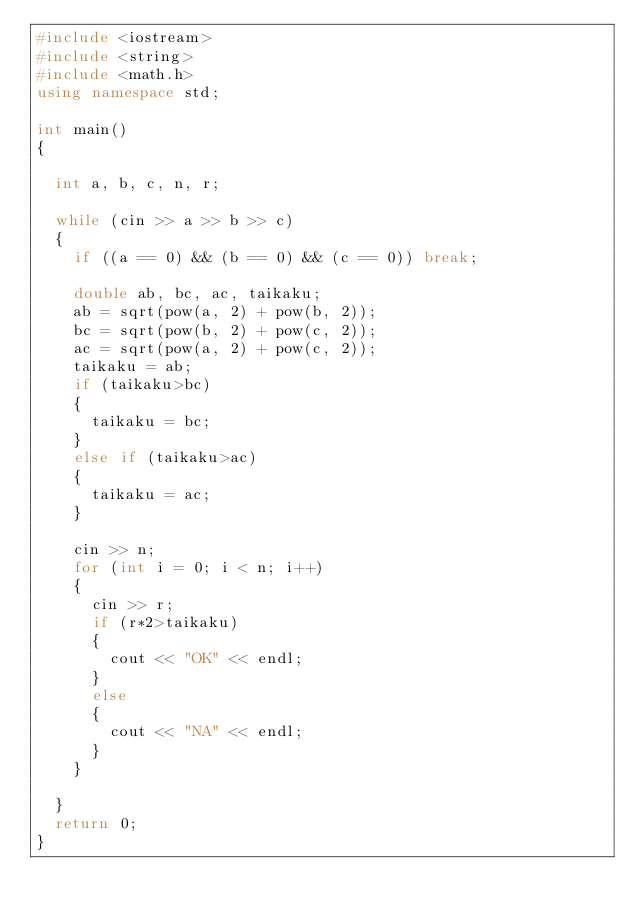Convert code to text. <code><loc_0><loc_0><loc_500><loc_500><_C++_>#include <iostream>
#include <string>
#include <math.h>
using namespace std;

int main()
{

	int a, b, c, n, r;

	while (cin >> a >> b >> c)
	{
		if ((a == 0) && (b == 0) && (c == 0)) break;

		double ab, bc, ac, taikaku;
		ab = sqrt(pow(a, 2) + pow(b, 2));
		bc = sqrt(pow(b, 2) + pow(c, 2));
		ac = sqrt(pow(a, 2) + pow(c, 2));
		taikaku = ab;
		if (taikaku>bc)
		{
			taikaku = bc;
		}
		else if (taikaku>ac)
		{
			taikaku = ac;
		}

		cin >> n;
		for (int i = 0; i < n; i++)
		{
			cin >> r;
			if (r*2>taikaku)
			{
				cout << "OK" << endl;
			}
			else
			{
				cout << "NA" << endl;
			}
		}

	}
	return 0;
}</code> 